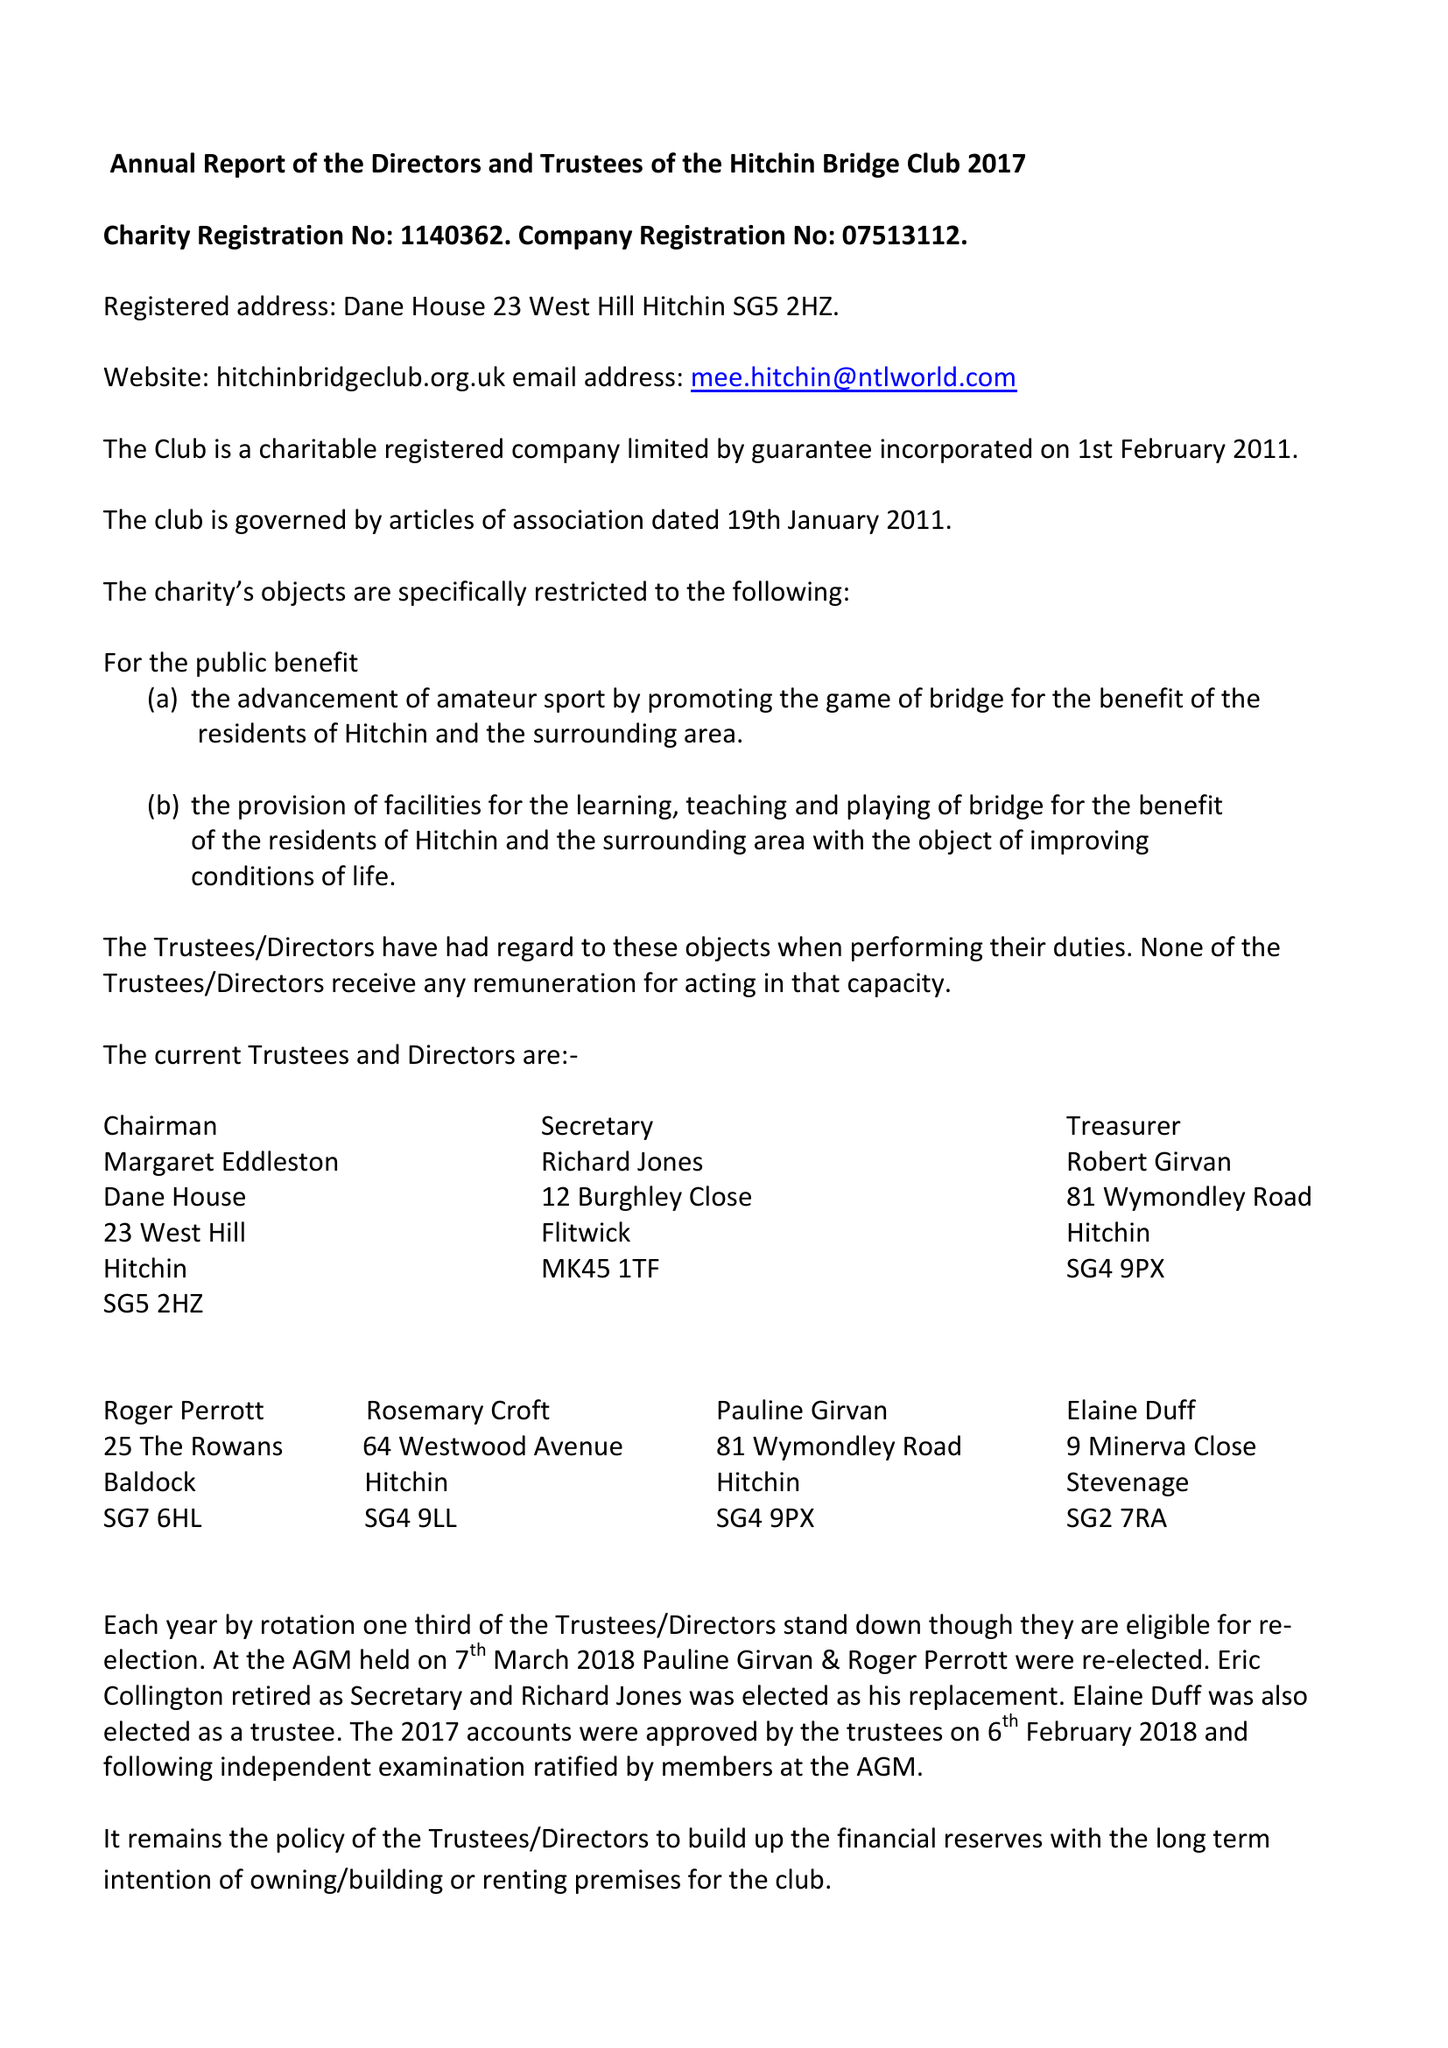What is the value for the income_annually_in_british_pounds?
Answer the question using a single word or phrase. 28890.00 